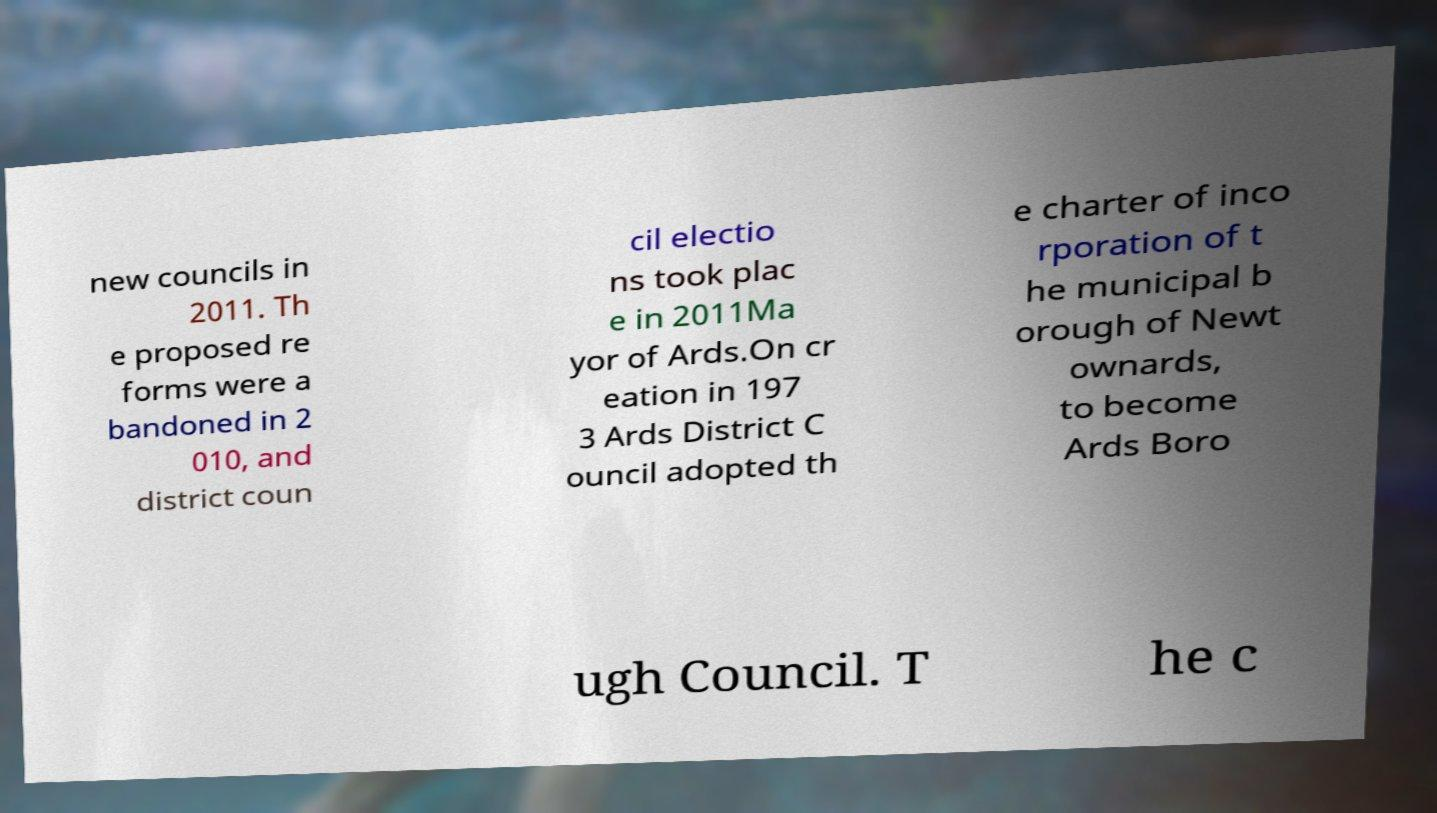Please identify and transcribe the text found in this image. new councils in 2011. Th e proposed re forms were a bandoned in 2 010, and district coun cil electio ns took plac e in 2011Ma yor of Ards.On cr eation in 197 3 Ards District C ouncil adopted th e charter of inco rporation of t he municipal b orough of Newt ownards, to become Ards Boro ugh Council. T he c 